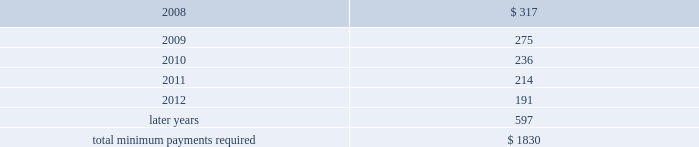Notes to consolidated financial statements at december 31 , 2007 , future minimum rental payments required under operating leases for continuing operations that have initial or remaining noncancelable lease terms in excess of one year , net of sublease rental income , most of which pertain to real estate leases , are as follows : ( millions ) .
Aon corporation .
What is the decrease observed in the future minimum rental payments during 2008 and 2009? 
Rationale: it is the difference between those values .
Computations: (275 - 317)
Answer: -42.0. Notes to consolidated financial statements at december 31 , 2007 , future minimum rental payments required under operating leases for continuing operations that have initial or remaining noncancelable lease terms in excess of one year , net of sublease rental income , most of which pertain to real estate leases , are as follows : ( millions ) .
Aon corporation .
What is the percentual decrease observed in the future minimum rental payments during 2008 and 2009? 
Rationale: it is the variation between those values divided by the initial one , then turned into a percentage .
Computations: ((275 - 317) / 317)
Answer: -0.13249. 